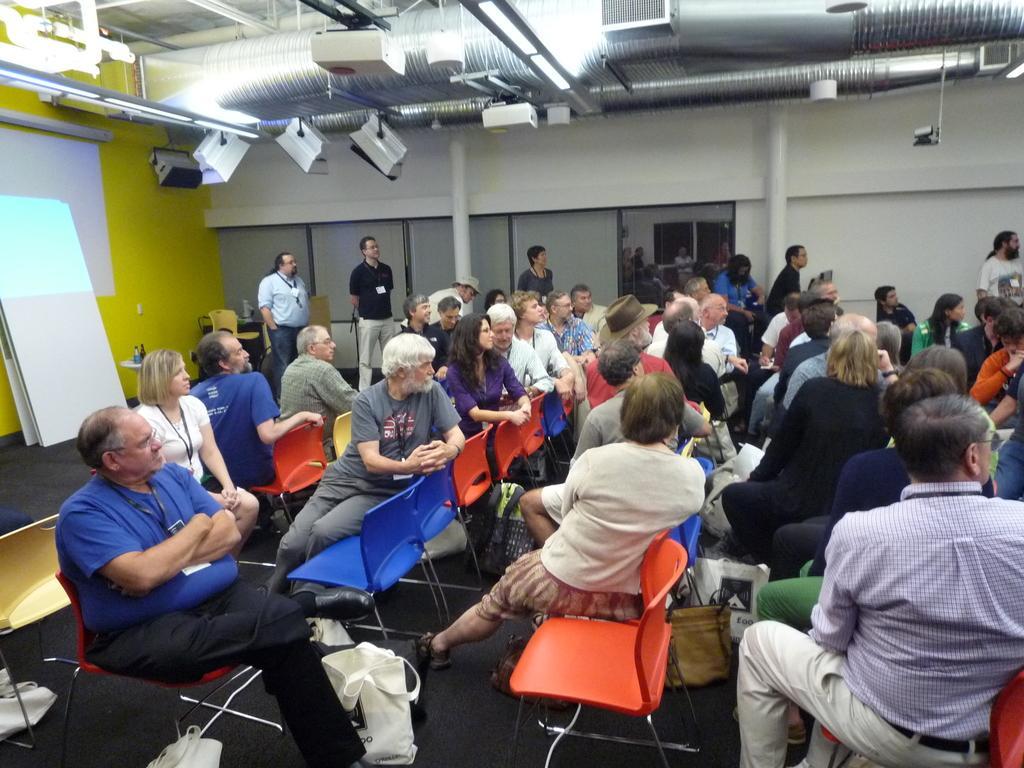In one or two sentences, can you explain what this image depicts? This picture is taken in a room in this few persons are sitting on the chairs and few are standing. On top of the floor there are lights and pipes. At the left side there is a screen. Bottom of image there are few bags on the floor. Person at the left side is sitting on chair wearing a blue shirt. 